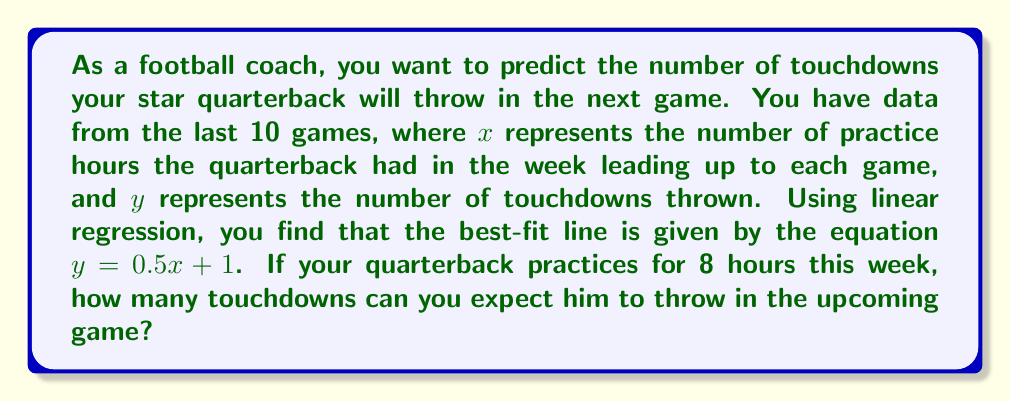Provide a solution to this math problem. To solve this problem, we'll use the linear regression model:

1) The given equation is $y = 0.5x + 1$, where:
   - $y$ is the predicted number of touchdowns
   - $x$ is the number of practice hours
   - 0.5 is the slope (indicating that for each additional hour of practice, we expect an increase of 0.5 touchdowns)
   - 1 is the y-intercept (the expected number of touchdowns with no practice)

2) We're told that the quarterback will practice for 8 hours this week, so $x = 8$.

3) To predict the number of touchdowns, we substitute $x = 8$ into the equation:

   $y = 0.5(8) + 1$

4) Simplify:
   $y = 4 + 1 = 5$

Therefore, based on this linear model, we can expect the quarterback to throw 5 touchdowns in the upcoming game after 8 hours of practice.
Answer: 5 touchdowns 